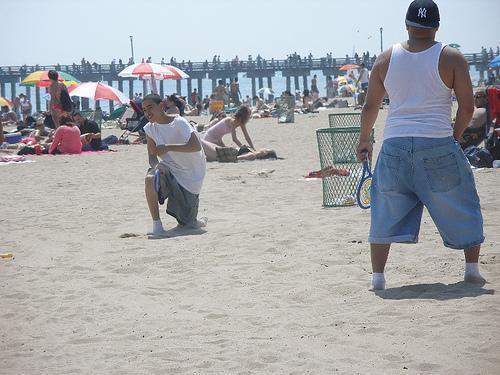How many people can be seen?
Give a very brief answer. 3. 